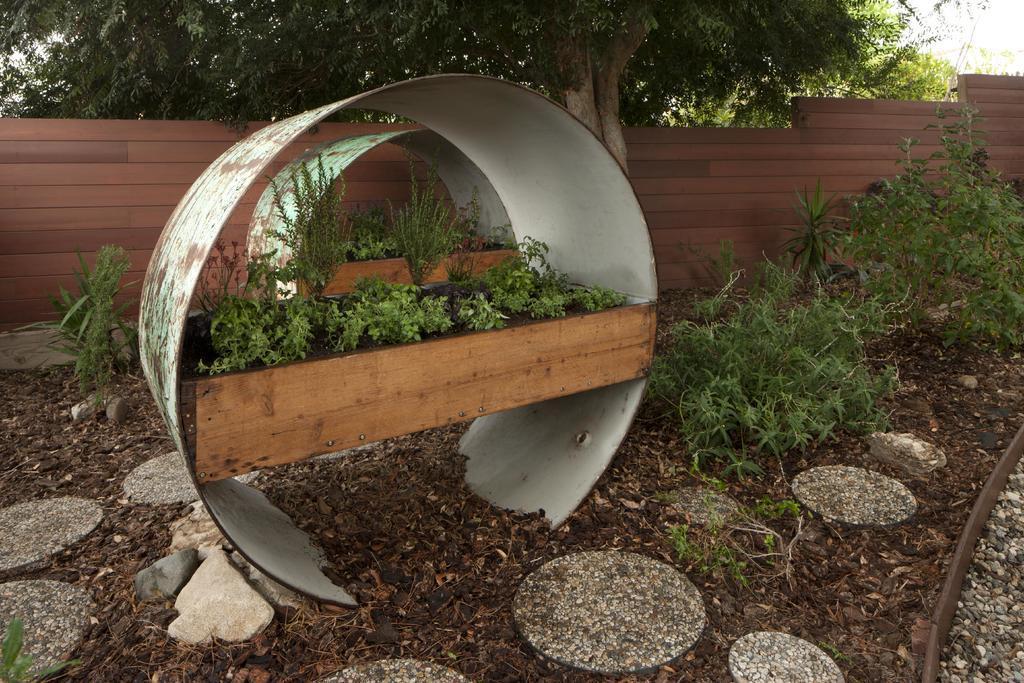Could you give a brief overview of what you see in this image? In the center of the image we can see plants placed on the wooden plank. At the bottom there are shrubs. In the background there are trees and a wall. 